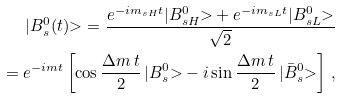Convert formula to latex. <formula><loc_0><loc_0><loc_500><loc_500>| B _ { s } ^ { 0 } ( t ) { > } = \frac { e ^ { - i m _ { s H } t } | B _ { s H } ^ { 0 } { > } + e ^ { - i m _ { s L } t } | B _ { s L } ^ { 0 } { > } } { \sqrt { 2 } } \\ = e ^ { - i m t } \left [ \cos \frac { \Delta m \, t } { 2 } \, | B _ { s } ^ { 0 } { > } - i \sin \frac { \Delta m \, t } { 2 } \, | \bar { B } _ { s } ^ { 0 } { > } \right ] \, ,</formula> 